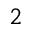<formula> <loc_0><loc_0><loc_500><loc_500>^ { 2 }</formula> 